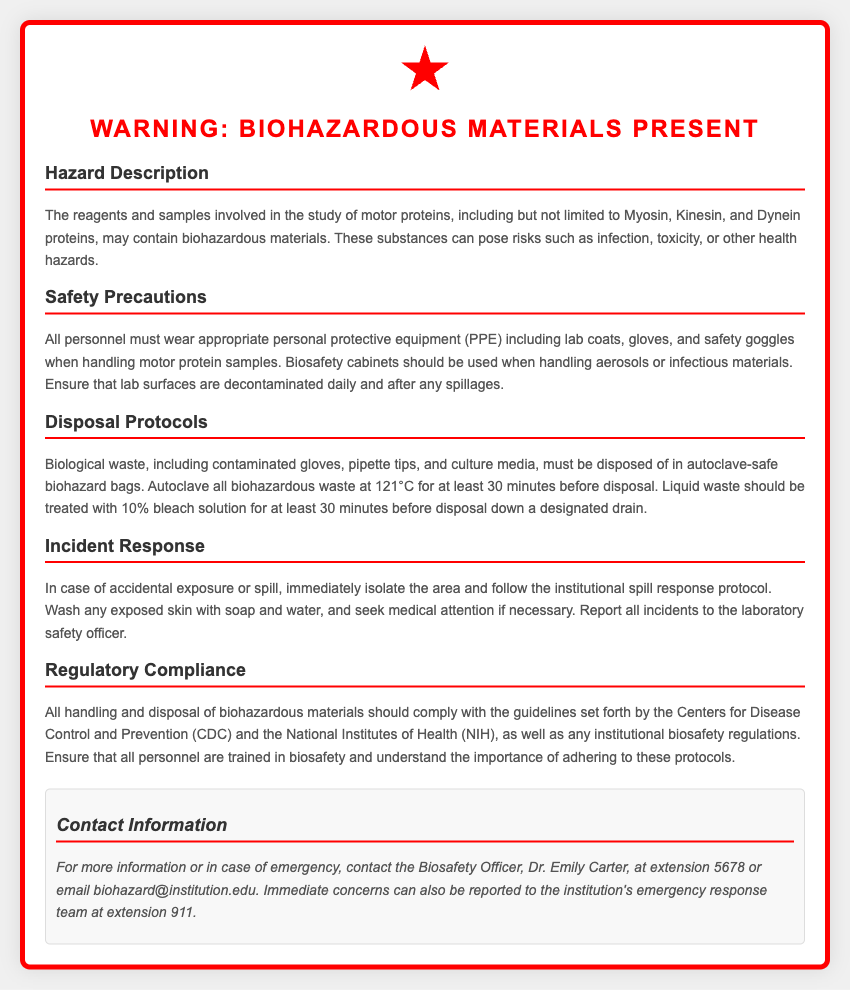What is the title of the warning label? The title is prominently displayed at the top of the label, indicating the presence of biohazardous materials.
Answer: Warning: Biohazardous Materials Present Which proteins are mentioned as potentially biohazardous? The document lists specific motor proteins that may be involved in the study and could contain biohazardous materials.
Answer: Myosin, Kinesin, and Dynein What personal protective equipment (PPE) is required? Specific types of PPE are mentioned in the section about safety precautions that must be worn by personnel.
Answer: Lab coats, gloves, and safety goggles What temperature is recommended for autoclaving biological waste? The disposal protocols specify the autoclaving temperature required for safe disposal of biohazardous waste.
Answer: 121°C Who should be contacted for more information? The contact section provides a specific name and contact details for someone responsible for biosafety inquiries.
Answer: Dr. Emily Carter What should be done in case of accidental exposure? The document outlines a response process that includes isolating the area and following protocols.
Answer: Isolate the area What is the treatment for liquid waste before disposal? The protocols describe a specific solution and duration for treating liquid waste prior to disposal.
Answer: 10% bleach solution for at least 30 minutes What institution's guidelines must be followed? The regulatory compliance section specifies two authoritative organizations whose guidelines must be adhered to.
Answer: CDC and NIH What should be reported after an incident? The incident response section highlights the importance of communication regarding safety incidents.
Answer: Report all incidents to the laboratory safety officer 